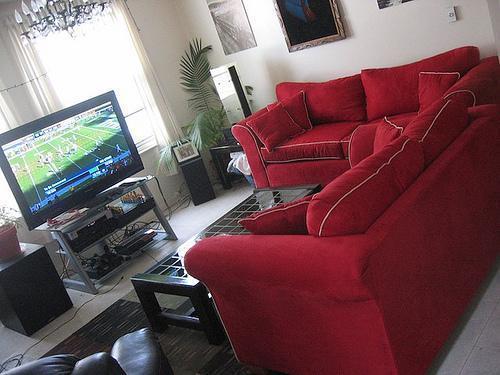How many couches can be seen?
Give a very brief answer. 2. How many chairs are visible?
Give a very brief answer. 1. How many horses are in the picture?
Give a very brief answer. 0. 